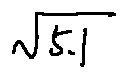<formula> <loc_0><loc_0><loc_500><loc_500>\sqrt { 5 . 1 }</formula> 